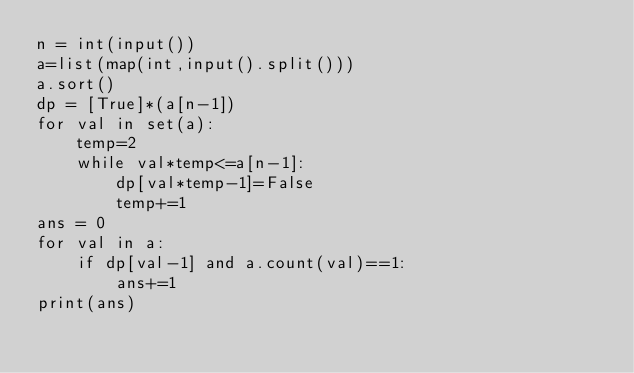Convert code to text. <code><loc_0><loc_0><loc_500><loc_500><_Python_>n = int(input())
a=list(map(int,input().split()))
a.sort()
dp = [True]*(a[n-1])
for val in set(a):
    temp=2
    while val*temp<=a[n-1]:
        dp[val*temp-1]=False
        temp+=1
ans = 0
for val in a:
    if dp[val-1] and a.count(val)==1:
        ans+=1
print(ans)</code> 